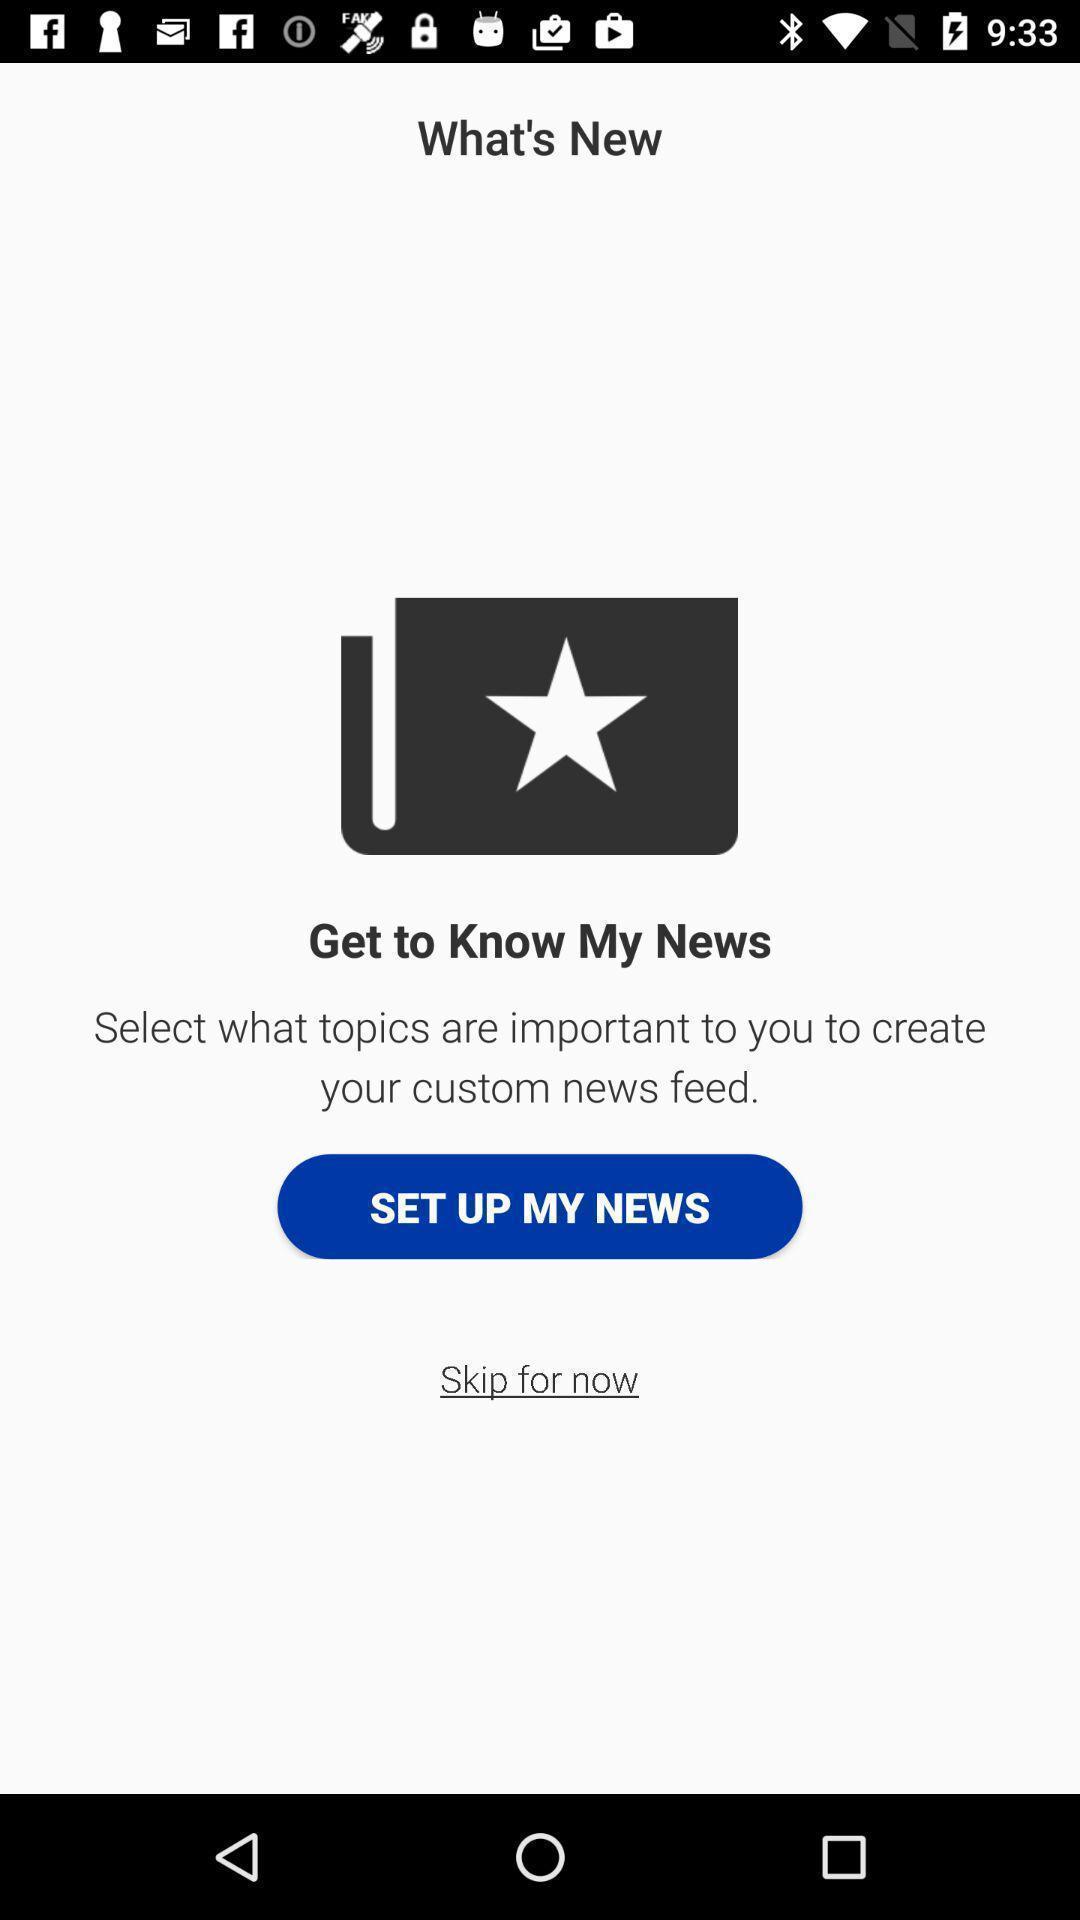Describe the content in this image. Screen displaying news feed feature information. 